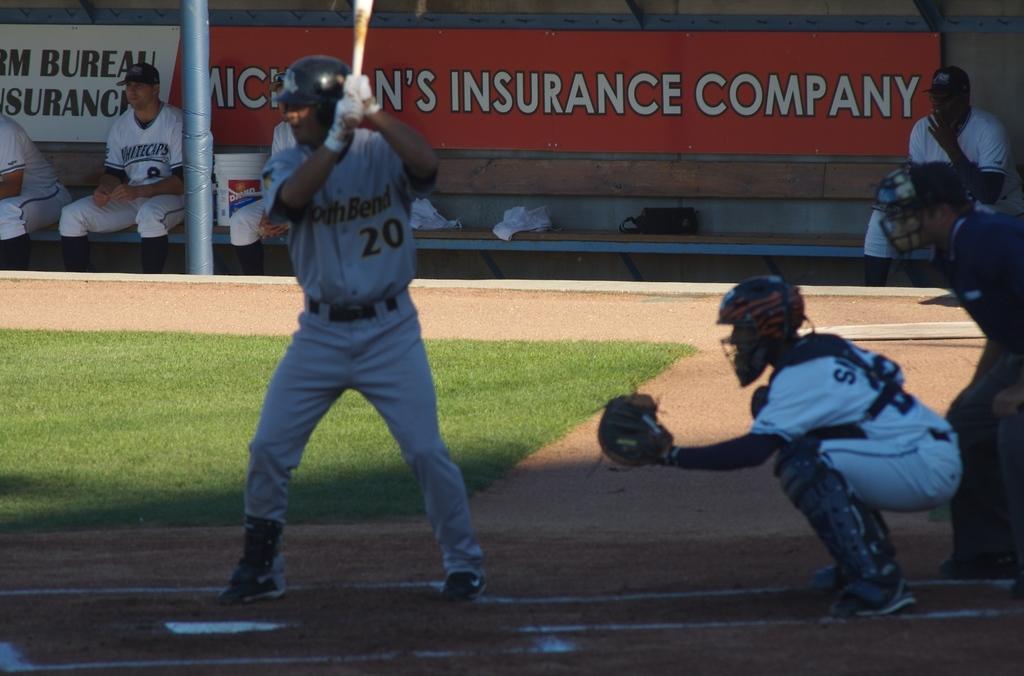What kind of company is on the poster in the back?
Give a very brief answer. Insurance. 